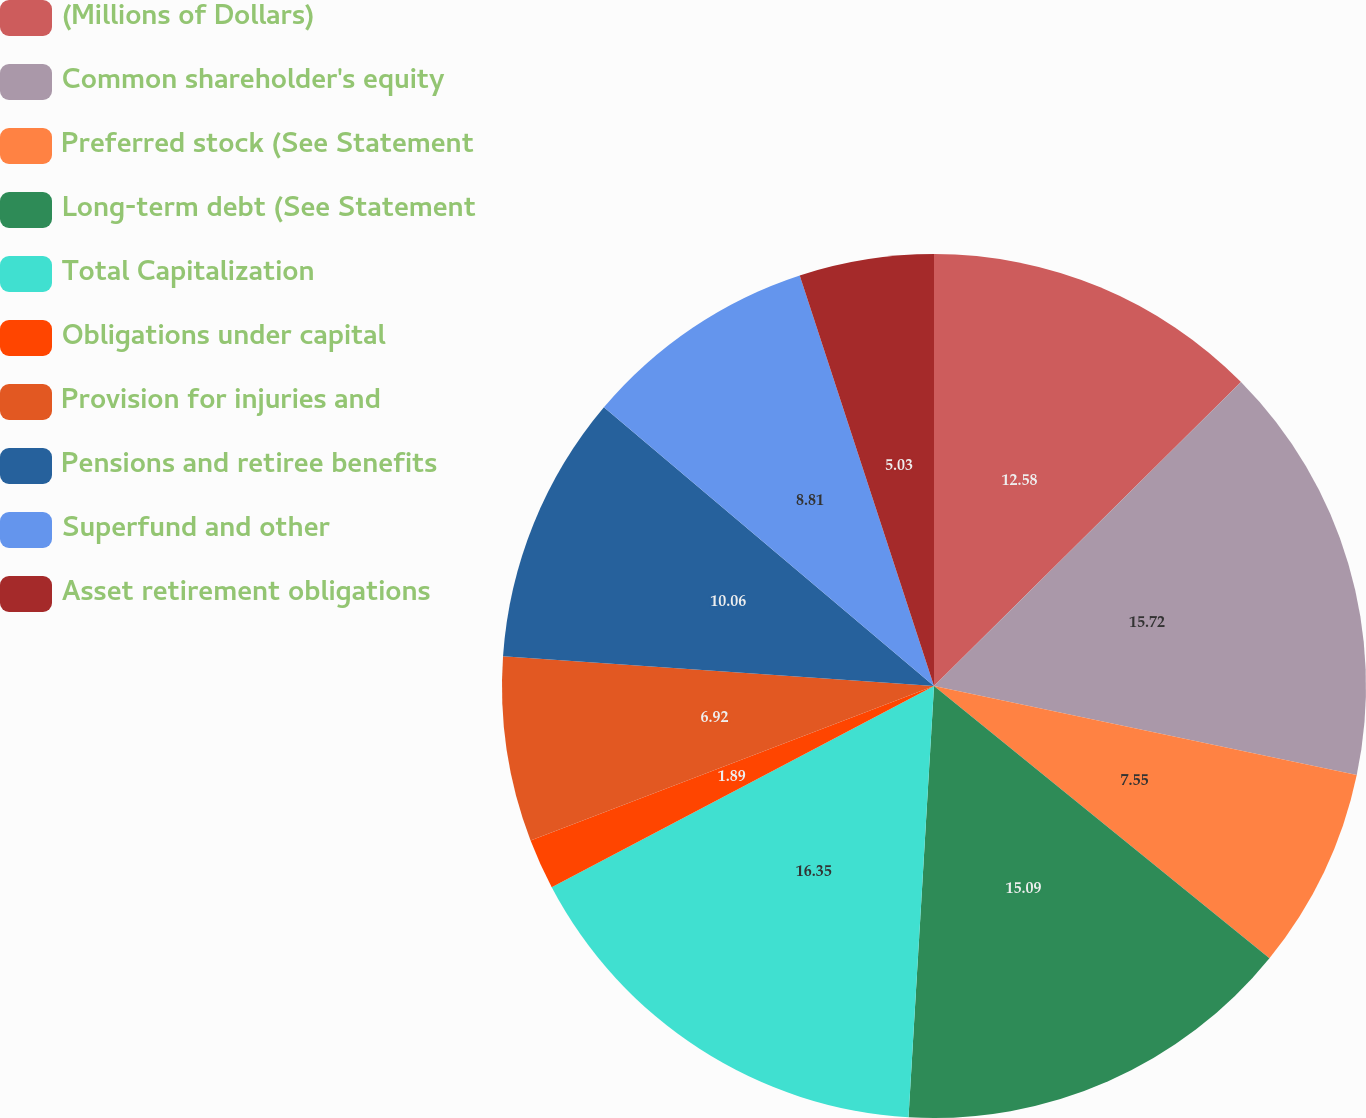Convert chart to OTSL. <chart><loc_0><loc_0><loc_500><loc_500><pie_chart><fcel>(Millions of Dollars)<fcel>Common shareholder's equity<fcel>Preferred stock (See Statement<fcel>Long-term debt (See Statement<fcel>Total Capitalization<fcel>Obligations under capital<fcel>Provision for injuries and<fcel>Pensions and retiree benefits<fcel>Superfund and other<fcel>Asset retirement obligations<nl><fcel>12.58%<fcel>15.72%<fcel>7.55%<fcel>15.09%<fcel>16.35%<fcel>1.89%<fcel>6.92%<fcel>10.06%<fcel>8.81%<fcel>5.03%<nl></chart> 